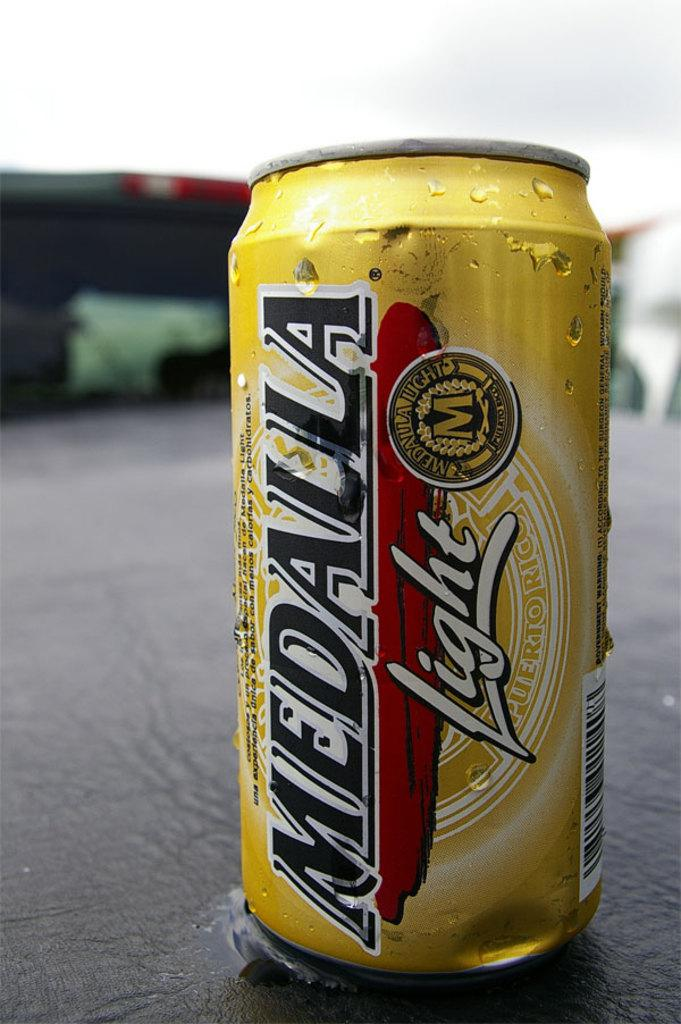<image>
Create a compact narrative representing the image presented. A yellow can says Medalla light.vertically on the side. 